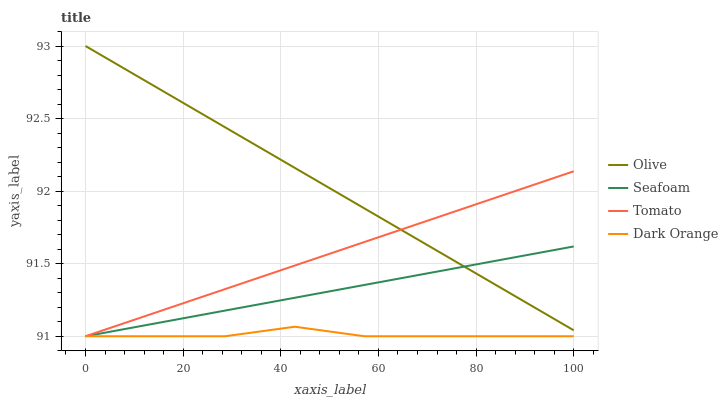Does Dark Orange have the minimum area under the curve?
Answer yes or no. Yes. Does Olive have the maximum area under the curve?
Answer yes or no. Yes. Does Tomato have the minimum area under the curve?
Answer yes or no. No. Does Tomato have the maximum area under the curve?
Answer yes or no. No. Is Tomato the smoothest?
Answer yes or no. Yes. Is Dark Orange the roughest?
Answer yes or no. Yes. Is Seafoam the smoothest?
Answer yes or no. No. Is Seafoam the roughest?
Answer yes or no. No. Does Tomato have the lowest value?
Answer yes or no. Yes. Does Olive have the highest value?
Answer yes or no. Yes. Does Tomato have the highest value?
Answer yes or no. No. Is Dark Orange less than Olive?
Answer yes or no. Yes. Is Olive greater than Dark Orange?
Answer yes or no. Yes. Does Dark Orange intersect Seafoam?
Answer yes or no. Yes. Is Dark Orange less than Seafoam?
Answer yes or no. No. Is Dark Orange greater than Seafoam?
Answer yes or no. No. Does Dark Orange intersect Olive?
Answer yes or no. No. 